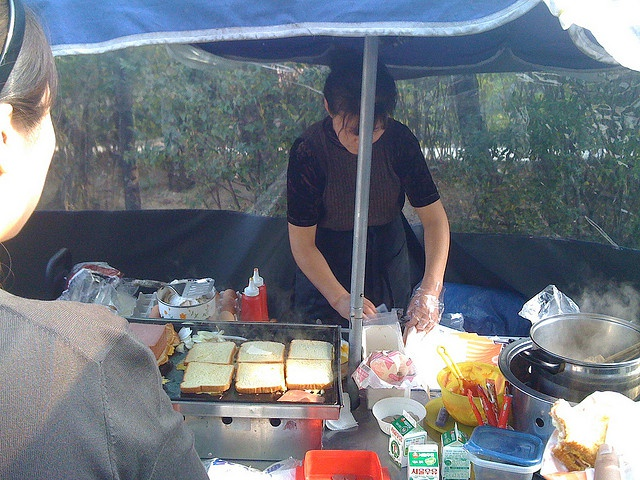Describe the objects in this image and their specific colors. I can see umbrella in gray and blue tones, people in gray, darkgray, and white tones, people in gray and black tones, bowl in gray, darkgray, black, and lightgray tones, and bowl in gray, gold, orange, and olive tones in this image. 